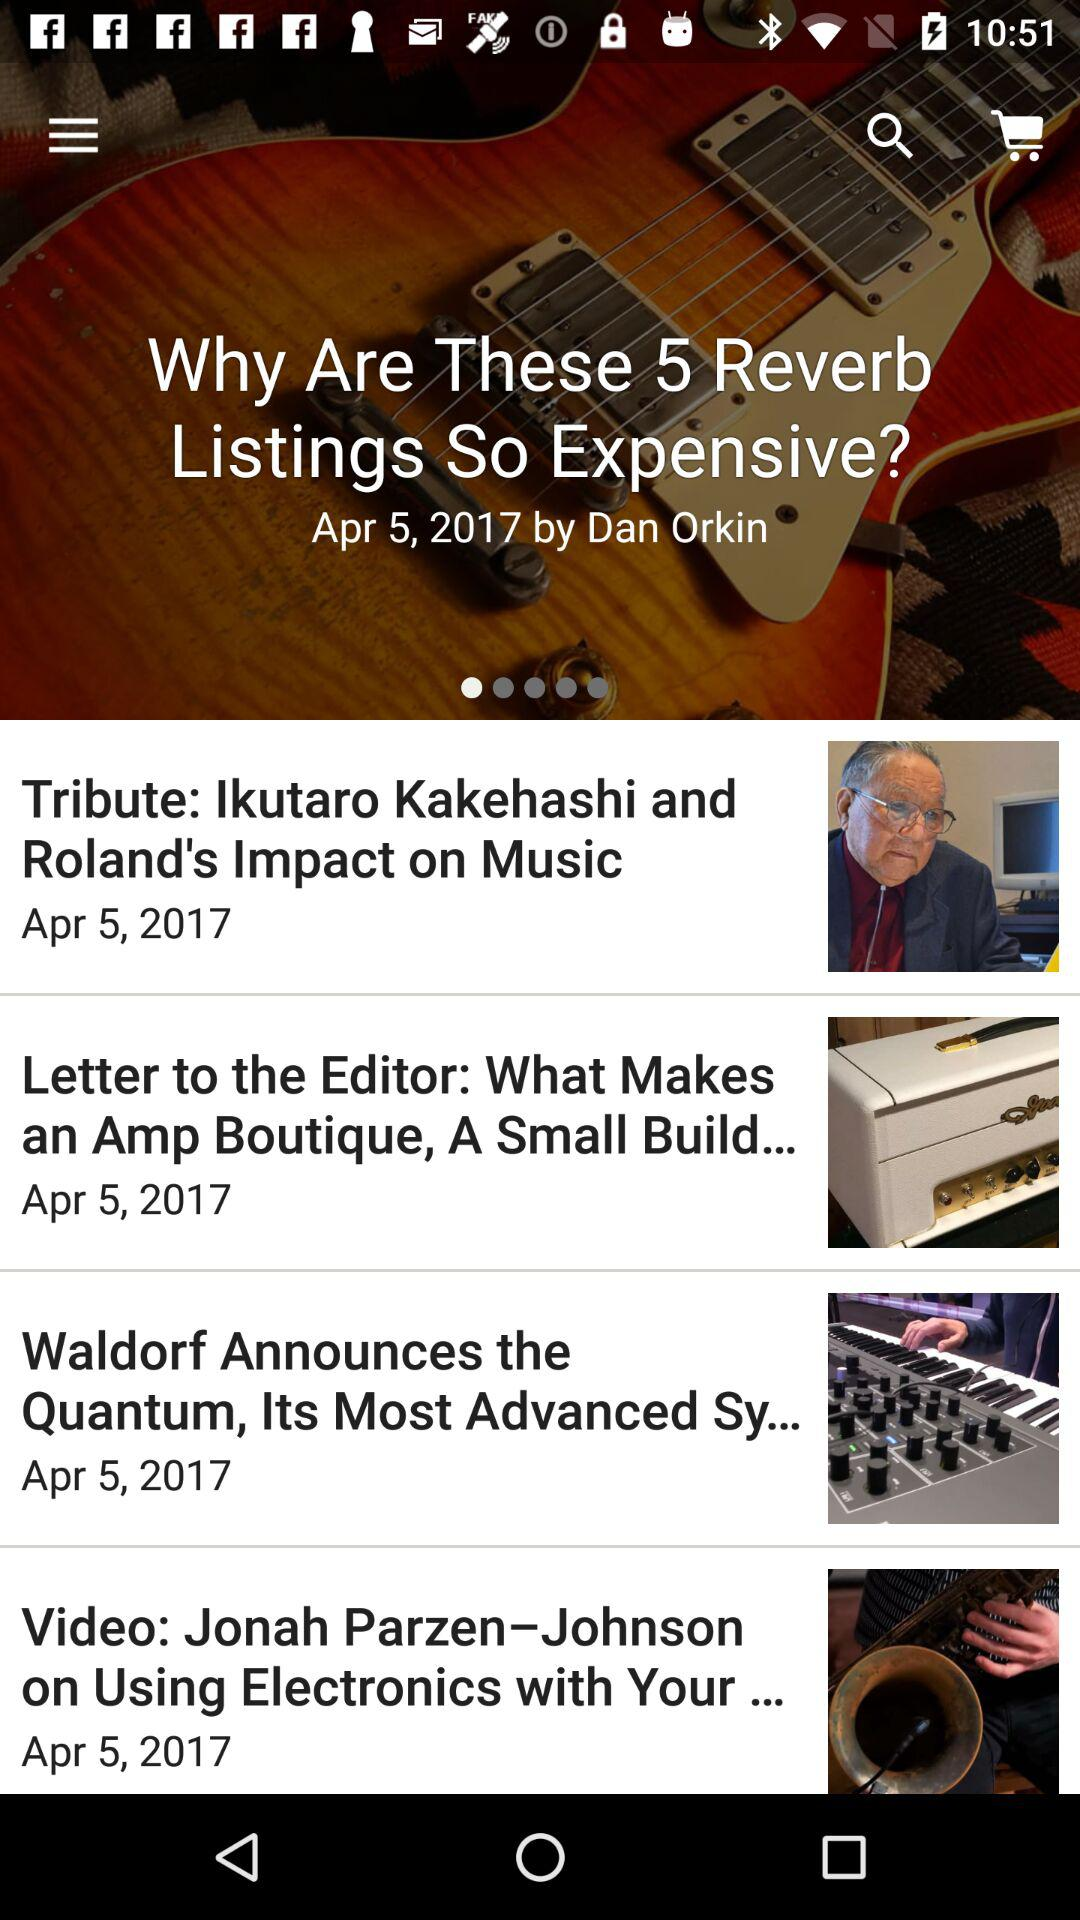What is the publication date? The date is April 5, 2017. 